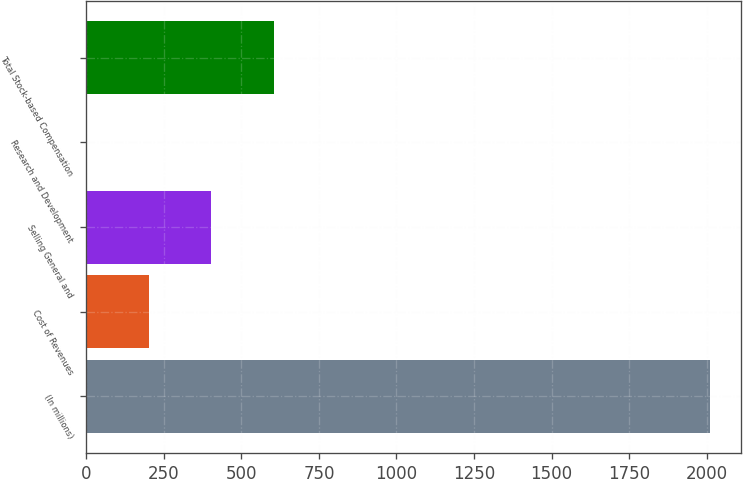Convert chart. <chart><loc_0><loc_0><loc_500><loc_500><bar_chart><fcel>(In millions)<fcel>Cost of Revenues<fcel>Selling General and<fcel>Research and Development<fcel>Total Stock-based Compensation<nl><fcel>2010<fcel>202.62<fcel>403.44<fcel>1.8<fcel>604.26<nl></chart> 